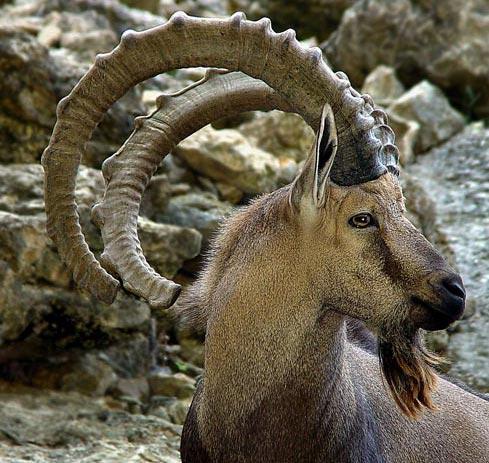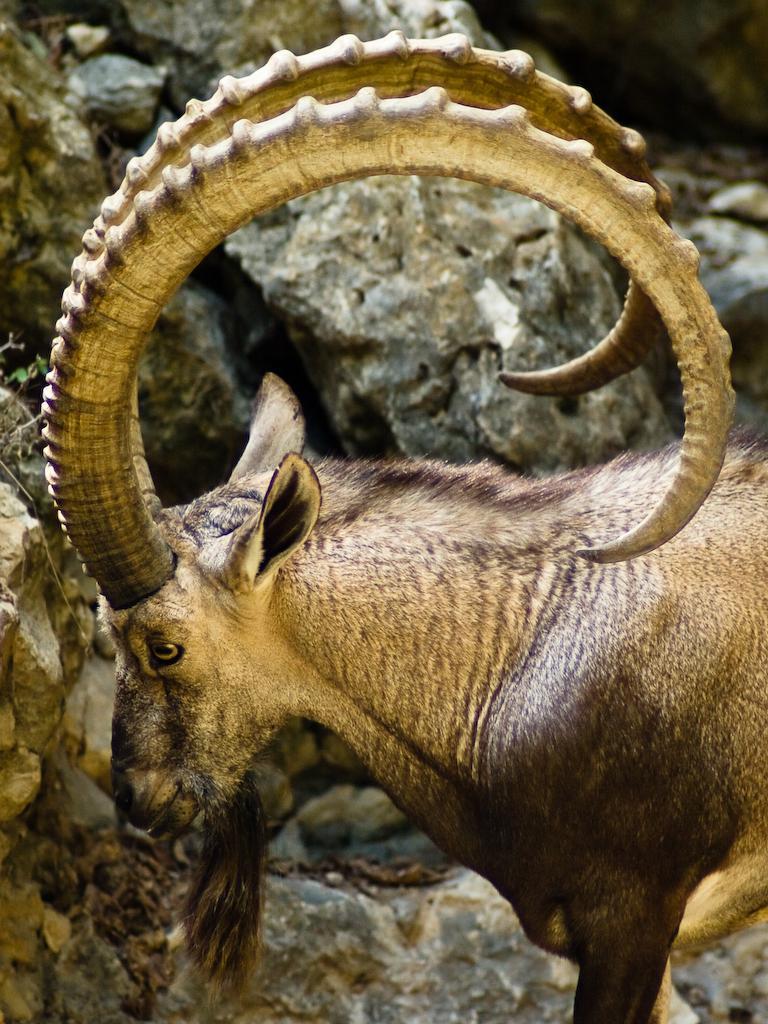The first image is the image on the left, the second image is the image on the right. For the images displayed, is the sentence "Horned rams in the  pair of images are facing toward each other." factually correct? Answer yes or no. Yes. 